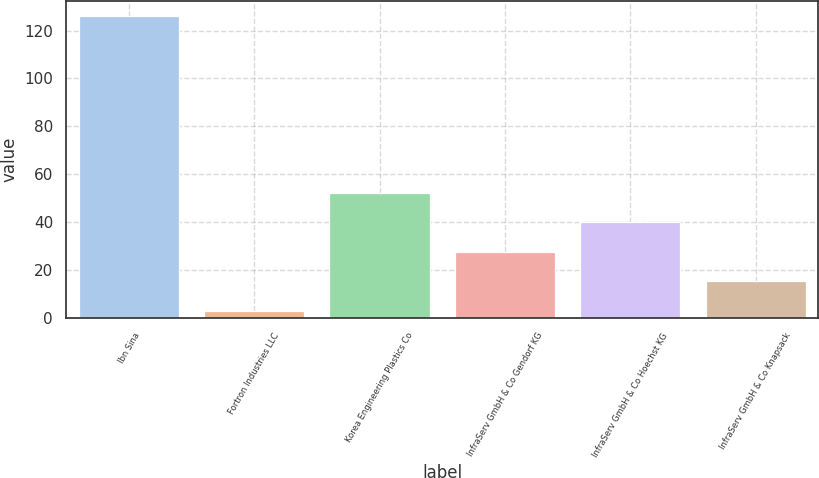Convert chart to OTSL. <chart><loc_0><loc_0><loc_500><loc_500><bar_chart><fcel>Ibn Sina<fcel>Fortron Industries LLC<fcel>Korea Engineering Plastics Co<fcel>InfraServ GmbH & Co Gendorf KG<fcel>InfraServ GmbH & Co Hoechst KG<fcel>InfraServ GmbH & Co Knapsack<nl><fcel>126<fcel>3<fcel>52.2<fcel>27.6<fcel>39.9<fcel>15.3<nl></chart> 